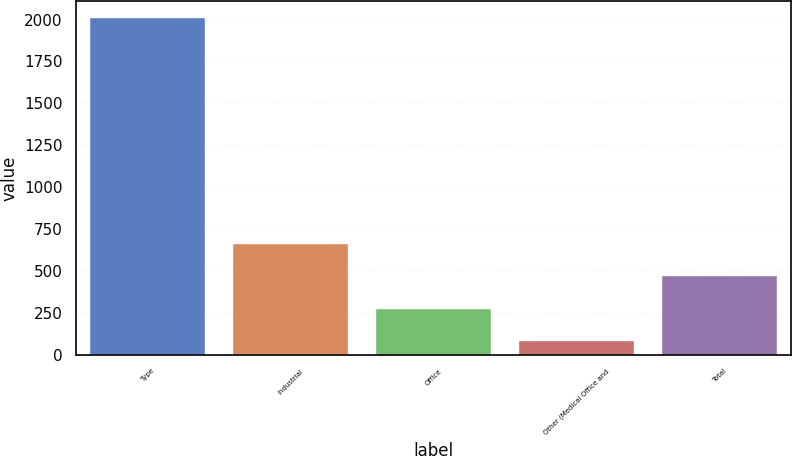Convert chart. <chart><loc_0><loc_0><loc_500><loc_500><bar_chart><fcel>Type<fcel>Industrial<fcel>Office<fcel>Other (Medical Office and<fcel>Total<nl><fcel>2009<fcel>660.73<fcel>275.51<fcel>82.9<fcel>468.12<nl></chart> 